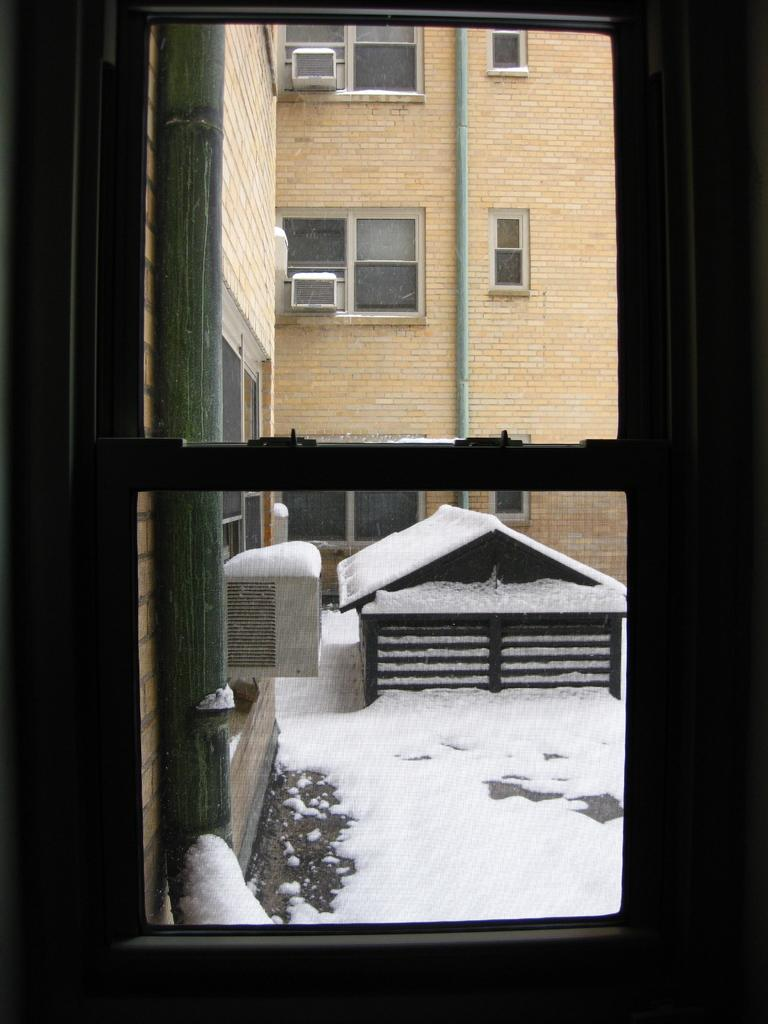What is the main feature in the center of the image? There is a window in the center of the image. What type of structure is visible in the image? There is a building in the image. What can be observed about the building's windows? The building has windows. What is located outside the window in the image? There is a small hut-like structure outside the window. What type of zinc is being offered to the person in the image? There is no zinc or person present in the image. How does the person in the image respond to the cough? There is no person or cough present in the image. 